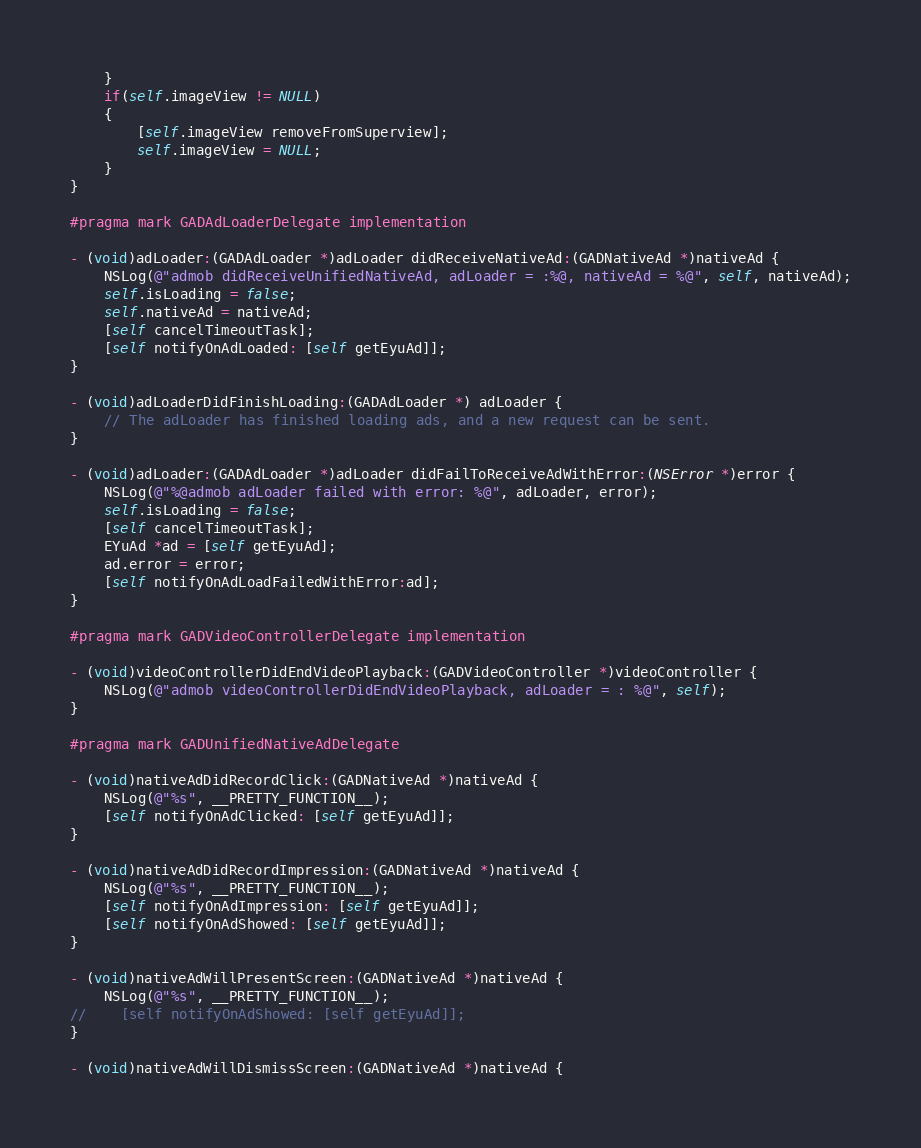Convert code to text. <code><loc_0><loc_0><loc_500><loc_500><_ObjectiveC_>    }
    if(self.imageView != NULL)
    {
        [self.imageView removeFromSuperview];
        self.imageView = NULL;
    }
}

#pragma mark GADAdLoaderDelegate implementation

- (void)adLoader:(GADAdLoader *)adLoader didReceiveNativeAd:(GADNativeAd *)nativeAd {
    NSLog(@"admob didReceiveUnifiedNativeAd, adLoader = :%@, nativeAd = %@", self, nativeAd);
    self.isLoading = false;
    self.nativeAd = nativeAd;
    [self cancelTimeoutTask];
    [self notifyOnAdLoaded: [self getEyuAd]];
}

- (void)adLoaderDidFinishLoading:(GADAdLoader *) adLoader {
    // The adLoader has finished loading ads, and a new request can be sent.
}

- (void)adLoader:(GADAdLoader *)adLoader didFailToReceiveAdWithError:(NSError *)error {
    NSLog(@"%@admob adLoader failed with error: %@", adLoader, error);
    self.isLoading = false;
    [self cancelTimeoutTask];
    EYuAd *ad = [self getEyuAd];
    ad.error = error;
    [self notifyOnAdLoadFailedWithError:ad];
}

#pragma mark GADVideoControllerDelegate implementation

- (void)videoControllerDidEndVideoPlayback:(GADVideoController *)videoController {
    NSLog(@"admob videoControllerDidEndVideoPlayback, adLoader = : %@", self);
}

#pragma mark GADUnifiedNativeAdDelegate

- (void)nativeAdDidRecordClick:(GADNativeAd *)nativeAd {
    NSLog(@"%s", __PRETTY_FUNCTION__);
    [self notifyOnAdClicked: [self getEyuAd]];
}

- (void)nativeAdDidRecordImpression:(GADNativeAd *)nativeAd {
    NSLog(@"%s", __PRETTY_FUNCTION__);
    [self notifyOnAdImpression: [self getEyuAd]];
    [self notifyOnAdShowed: [self getEyuAd]];
}

- (void)nativeAdWillPresentScreen:(GADNativeAd *)nativeAd {
    NSLog(@"%s", __PRETTY_FUNCTION__);
//    [self notifyOnAdShowed: [self getEyuAd]];
}

- (void)nativeAdWillDismissScreen:(GADNativeAd *)nativeAd {</code> 